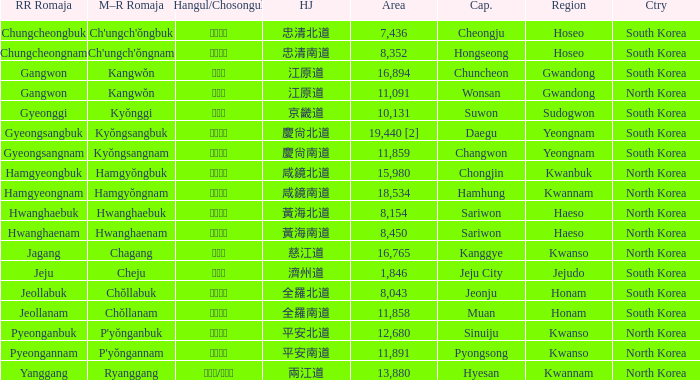Which capital has a Hangul of 경상남도? Changwon. 